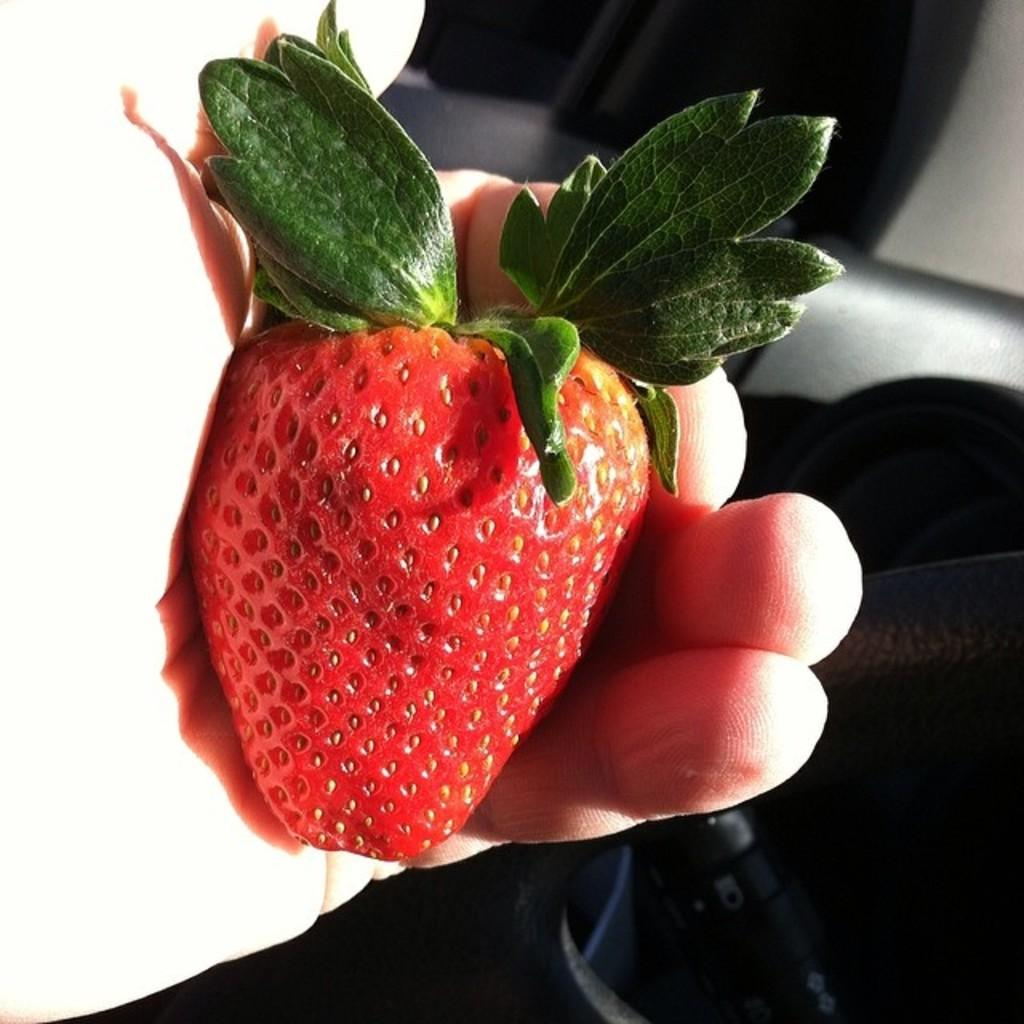What is the hand holding in the image? There is a hand holding a strawberry in the image. What can be seen on the wall in the image? There are curtains on a wall in the image. Can you describe the object at the bottom of the image? Unfortunately, the provided facts do not give enough information to describe the object at the bottom of the image. What type of tin can be seen on the island in the image? There is no tin or island present in the image. How many patches are visible on the hand holding the strawberry? There is no mention of patches on the hand holding the strawberry in the provided facts. 